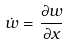Convert formula to latex. <formula><loc_0><loc_0><loc_500><loc_500>\dot { w } = \frac { \partial w } { \partial x }</formula> 